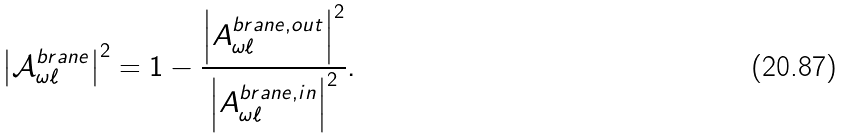<formula> <loc_0><loc_0><loc_500><loc_500>\left | { \mathcal { A } } _ { \omega \ell } ^ { b r a n e } \right | ^ { 2 } = 1 - \frac { \left | A _ { \omega \ell } ^ { b r a n e , o u t } \right | ^ { 2 } } { \left | A _ { \omega \ell } ^ { b r a n e , i n } \right | ^ { 2 } } .</formula> 